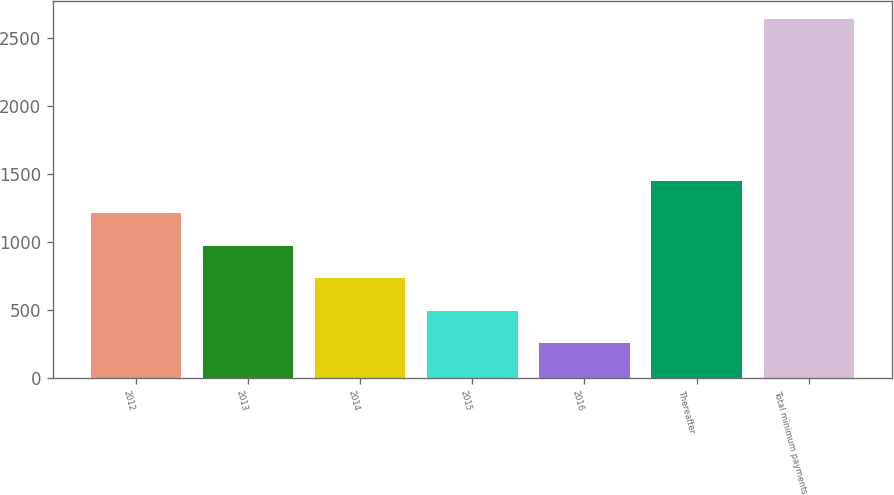<chart> <loc_0><loc_0><loc_500><loc_500><bar_chart><fcel>2012<fcel>2013<fcel>2014<fcel>2015<fcel>2016<fcel>Thereafter<fcel>Total minimum payments<nl><fcel>1209.8<fcel>971.6<fcel>733.4<fcel>495.2<fcel>257<fcel>1448<fcel>2639<nl></chart> 